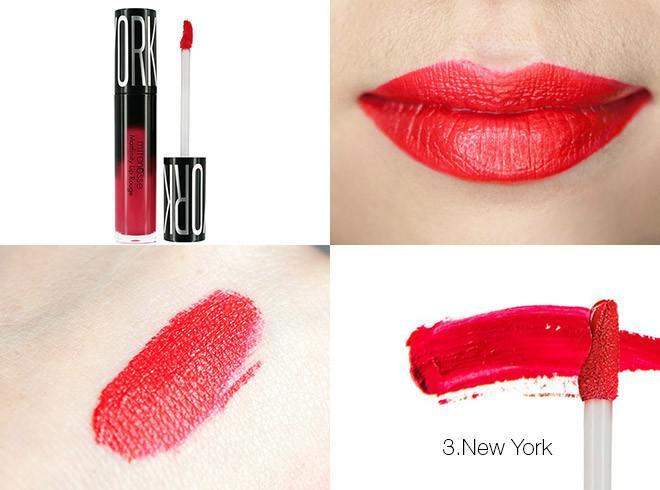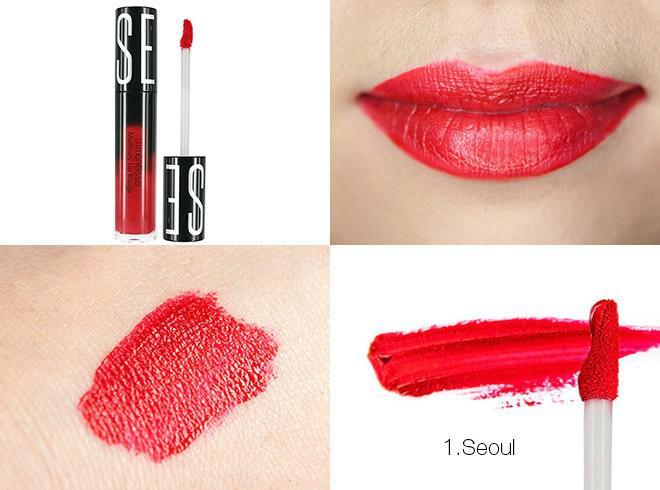The first image is the image on the left, the second image is the image on the right. Analyze the images presented: Is the assertion "The woman's eyes can be seen in one of the images" valid? Answer yes or no. No. The first image is the image on the left, the second image is the image on the right. Examine the images to the left and right. Is the description "A woman's teeth are visible in at least one of the images." accurate? Answer yes or no. No. 